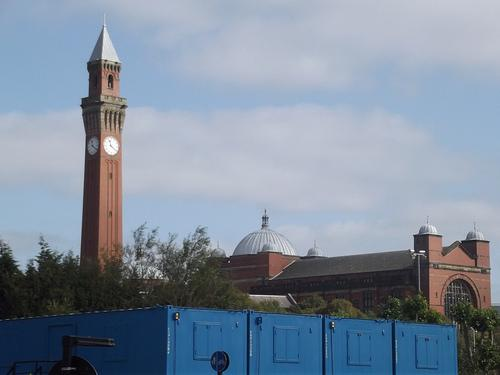For the product advertisement task, promote the blue skateboard as a perfect gift for the holidays. This holiday season, surprise your loved ones with the ultimate gift – our versatile blue skateboard! Glide effortlessly through the white snow and make unforgettable memories. Order now and join the fun! Identify an object in the image that has a unique color compared to its surroundings. The blue skateboard lying in the white snow stands out due to its unique color contrast against the surrounding environment. For the visual entailment task, describe the relationship between the clock tower and the blue sky. The clock tower is standing tall and prominent against a beautiful blue sky filled with puffy white clouds, creating an eye-catching and picturesque scene. Choose the best caption for the multi-choice VQA task: 1) A gloomy day with empty streets 2) A sunny day with a blue sky, clock tower, and trailers 3) A snowy landscape with lots of people skiing A sunny day with a blue sky, clock tower, and trailers For the multi-choice VQA task, select the most suitable location for a person to go cloud watching: 1) beside the clock tower, 2) behind the trailers, or 3) on top of the horizontal brick building. Beside the clock tower Based on the image, compose a product advertisement for a skateboard. Introducing the sleek new blue skateboard, perfect for shredding on any terrain, even in the white snow! Be the coolest skater with the ultimate in design, performance, and style. Get yours now! List the various objects found in the lower part of the image. Four trailers, trees behind the trailers, and a blue skateboard lying in the white snow are some of the objects found at the bottom of the image. 